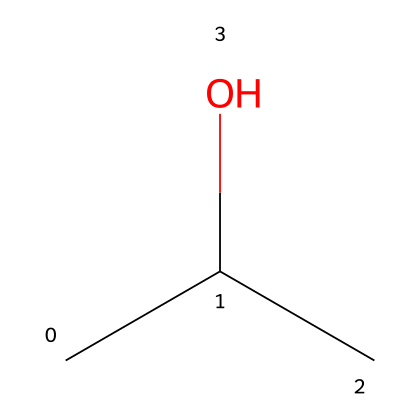What is the name of this chemical? The chemical structure provided corresponds to isopropyl alcohol, which is commonly used as a solvent and cleaning agent. The presence of the hydroxyl group indicates its classification as an alcohol.
Answer: isopropyl alcohol How many carbon atoms are in isopropyl alcohol? The SMILES representation shows "CC(C)", indicating there are three carbon atoms connected in the structure. Each "C" represents a carbon atom.
Answer: three What type of functional group does isopropyl alcohol contain? The structure shows a hydroxyl group (-OH) attached to one of the carbon atoms, which qualifies it as an alcohol due to the presence of this functional group.
Answer: hydroxyl group How many hydrogen atoms are in isopropyl alcohol? Each carbon in the structure typically bonds with enough hydrogen atoms to satisfy carbon's tetravalent nature. Counting the hydrogens in the structure leads to a total of eight hydrogen atoms connected to the three carbon atoms.
Answer: eight Is isopropyl alcohol polar or nonpolar? The presence of the hydroxyl group contributes to the polarity of isopropyl alcohol, as it can engage in hydrogen bonding with water, making it polar.
Answer: polar Is isopropyl alcohol considered a solvent? Yes, isopropyl alcohol acts as a solvent because it can dissolve a variety of polar and nonpolar substances due to its structure and properties.
Answer: yes 